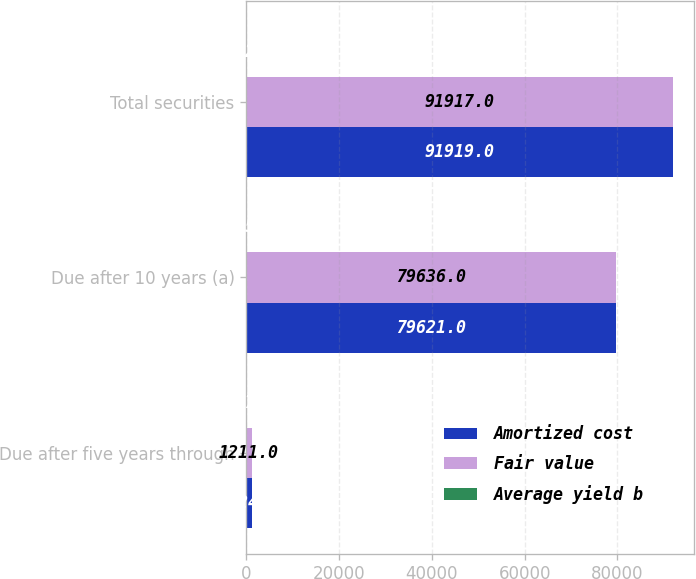Convert chart to OTSL. <chart><loc_0><loc_0><loc_500><loc_500><stacked_bar_chart><ecel><fcel>Due after five years through<fcel>Due after 10 years (a)<fcel>Total securities<nl><fcel>Amortized cost<fcel>1224<fcel>79621<fcel>91919<nl><fcel>Fair value<fcel>1211<fcel>79636<fcel>91917<nl><fcel>Average yield b<fcel>4.73<fcel>5.58<fcel>5.28<nl></chart> 